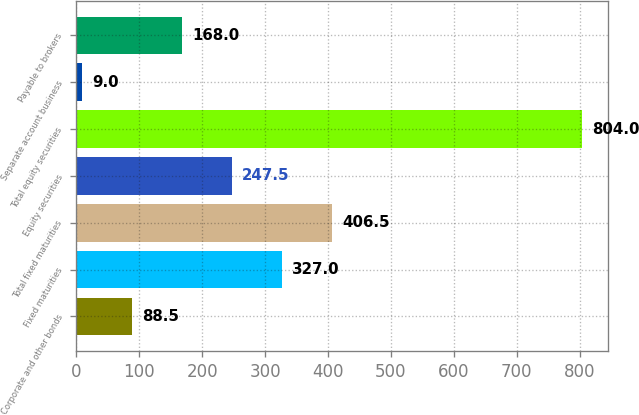Convert chart to OTSL. <chart><loc_0><loc_0><loc_500><loc_500><bar_chart><fcel>Corporate and other bonds<fcel>Fixed maturities<fcel>Total fixed maturities<fcel>Equity securities<fcel>Total equity securities<fcel>Separate account business<fcel>Payable to brokers<nl><fcel>88.5<fcel>327<fcel>406.5<fcel>247.5<fcel>804<fcel>9<fcel>168<nl></chart> 